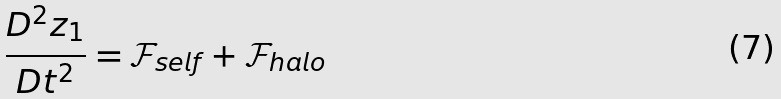Convert formula to latex. <formula><loc_0><loc_0><loc_500><loc_500>\frac { D ^ { 2 } z _ { 1 } } { D t ^ { 2 } } = { { \mathcal { F } } _ { s e l f } } + { { \mathcal { F } } _ { h a l o } }</formula> 